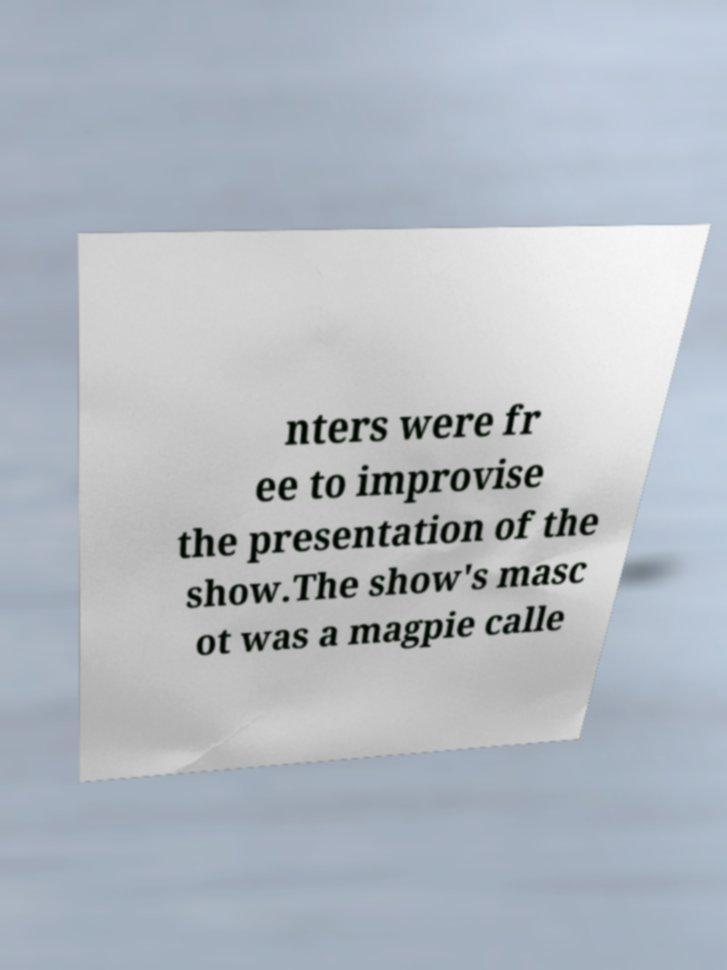Can you read and provide the text displayed in the image?This photo seems to have some interesting text. Can you extract and type it out for me? nters were fr ee to improvise the presentation of the show.The show's masc ot was a magpie calle 